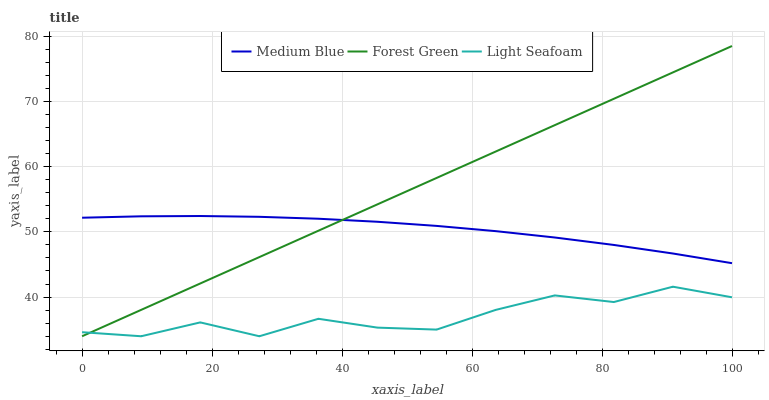Does Light Seafoam have the minimum area under the curve?
Answer yes or no. Yes. Does Forest Green have the maximum area under the curve?
Answer yes or no. Yes. Does Medium Blue have the minimum area under the curve?
Answer yes or no. No. Does Medium Blue have the maximum area under the curve?
Answer yes or no. No. Is Forest Green the smoothest?
Answer yes or no. Yes. Is Light Seafoam the roughest?
Answer yes or no. Yes. Is Medium Blue the smoothest?
Answer yes or no. No. Is Medium Blue the roughest?
Answer yes or no. No. Does Forest Green have the lowest value?
Answer yes or no. Yes. Does Medium Blue have the lowest value?
Answer yes or no. No. Does Forest Green have the highest value?
Answer yes or no. Yes. Does Medium Blue have the highest value?
Answer yes or no. No. Is Light Seafoam less than Medium Blue?
Answer yes or no. Yes. Is Medium Blue greater than Light Seafoam?
Answer yes or no. Yes. Does Medium Blue intersect Forest Green?
Answer yes or no. Yes. Is Medium Blue less than Forest Green?
Answer yes or no. No. Is Medium Blue greater than Forest Green?
Answer yes or no. No. Does Light Seafoam intersect Medium Blue?
Answer yes or no. No. 